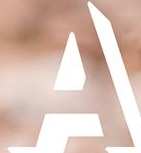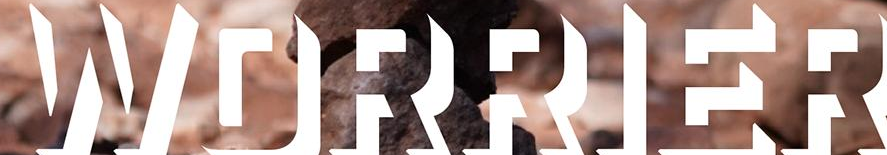Read the text content from these images in order, separated by a semicolon. A; WORRIER 